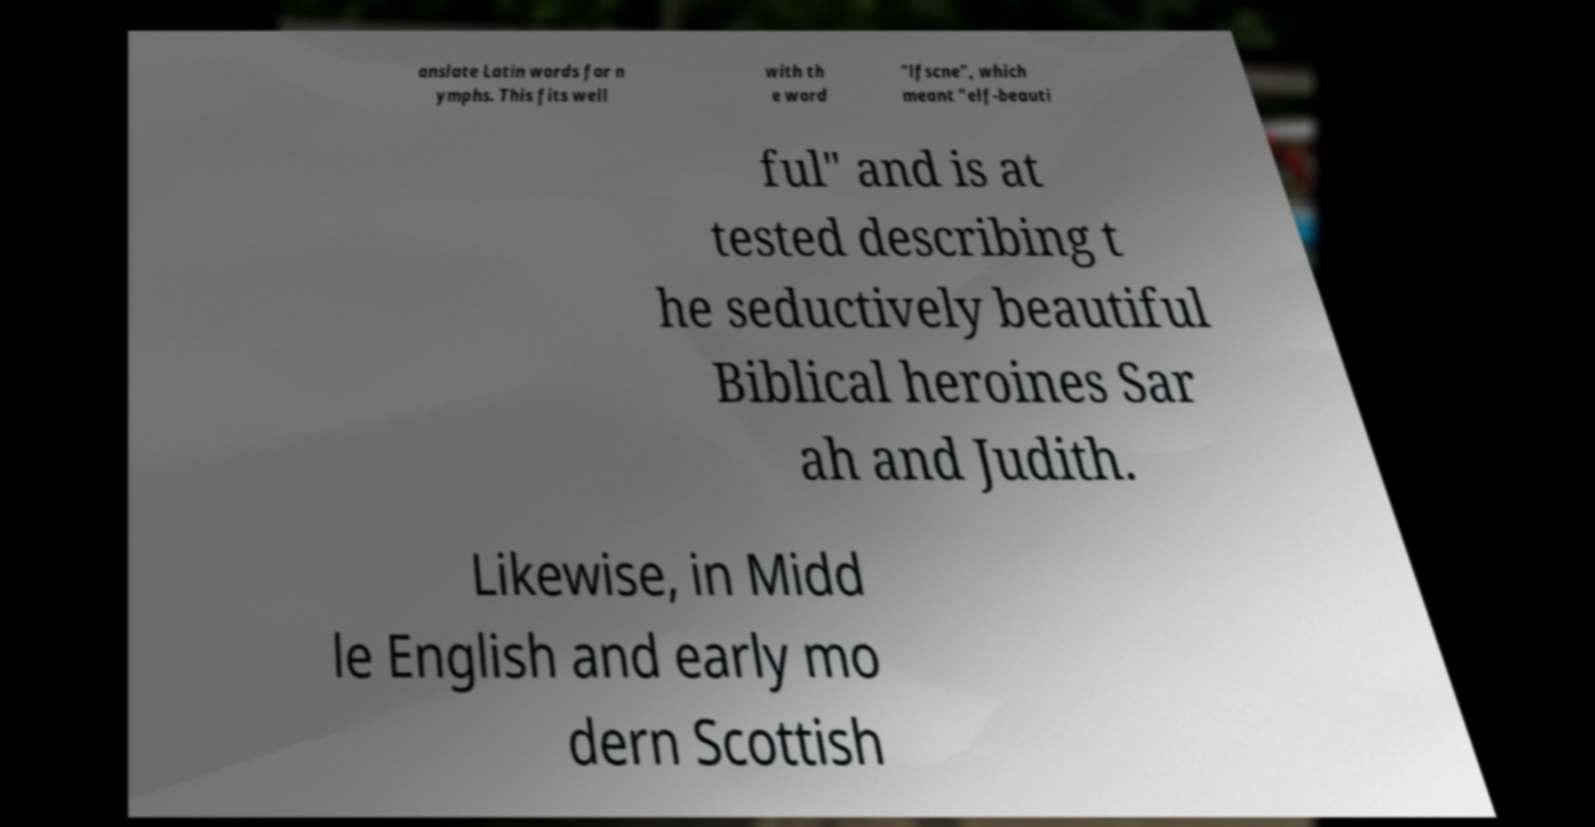What messages or text are displayed in this image? I need them in a readable, typed format. anslate Latin words for n ymphs. This fits well with th e word "lfscne", which meant "elf-beauti ful" and is at tested describing t he seductively beautiful Biblical heroines Sar ah and Judith. Likewise, in Midd le English and early mo dern Scottish 